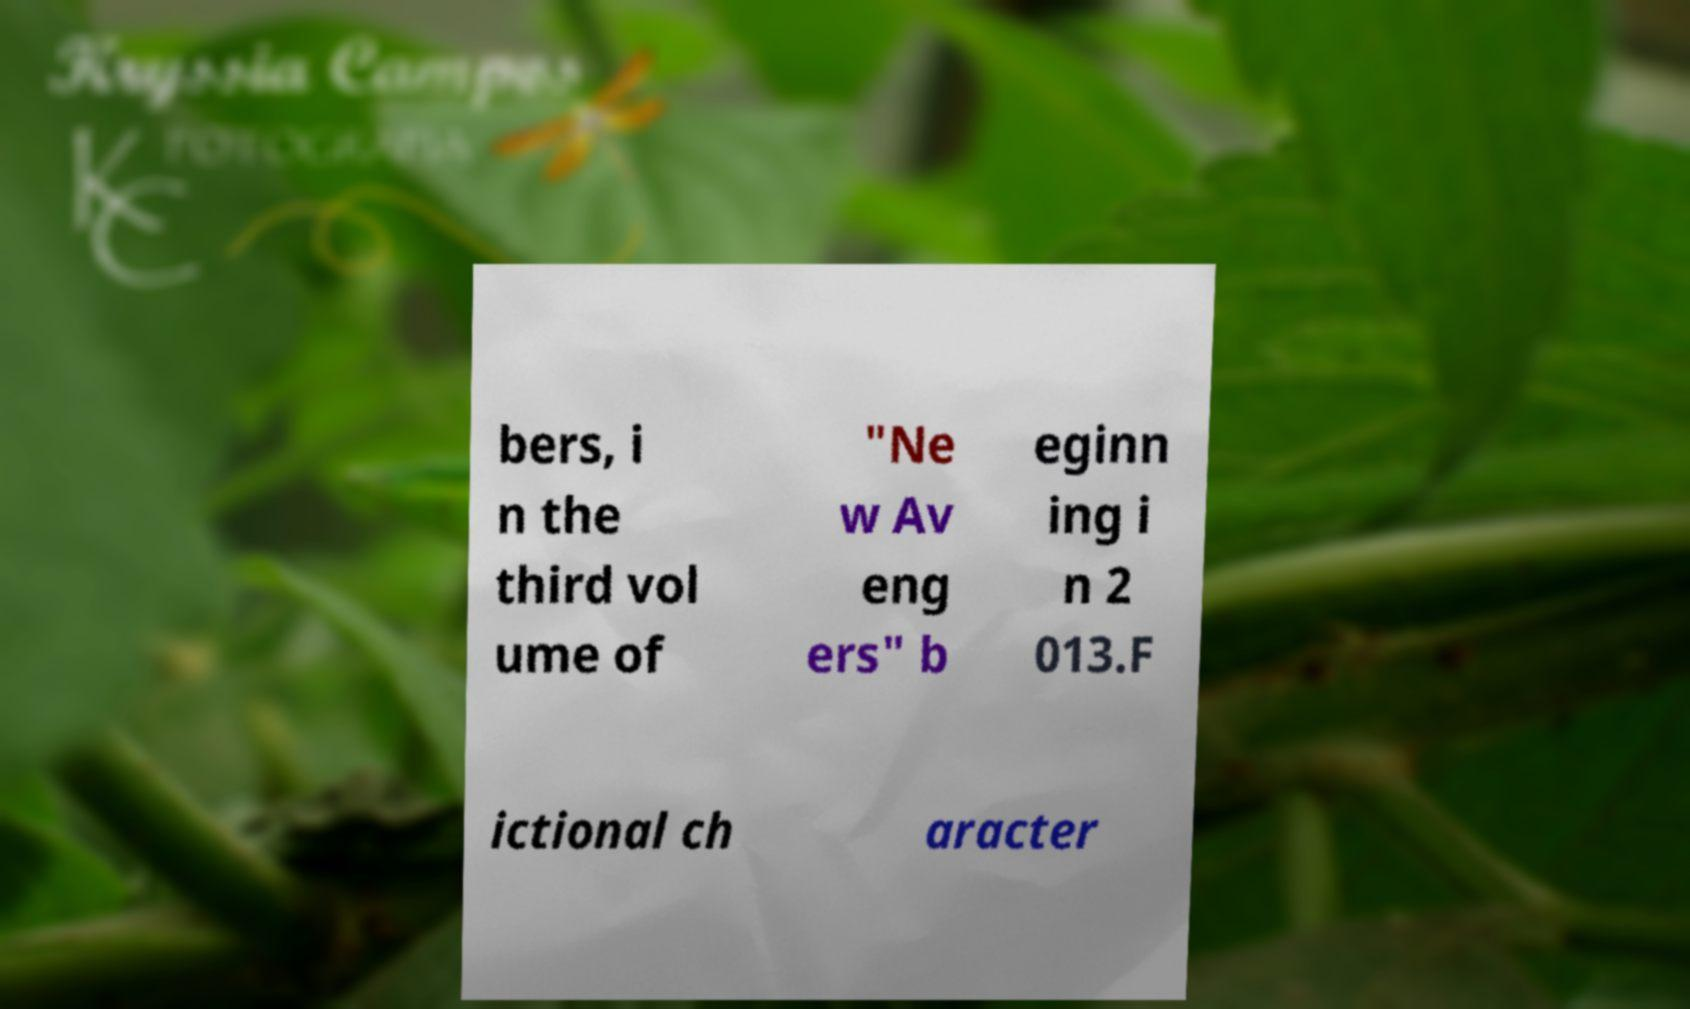There's text embedded in this image that I need extracted. Can you transcribe it verbatim? bers, i n the third vol ume of "Ne w Av eng ers" b eginn ing i n 2 013.F ictional ch aracter 